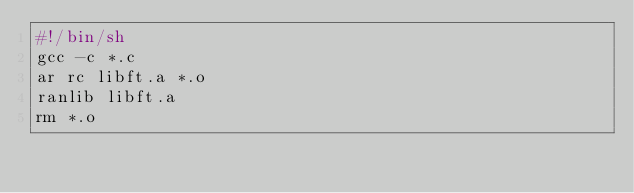Convert code to text. <code><loc_0><loc_0><loc_500><loc_500><_Bash_>#!/bin/sh
gcc -c *.c
ar rc libft.a *.o
ranlib libft.a
rm *.o

</code> 